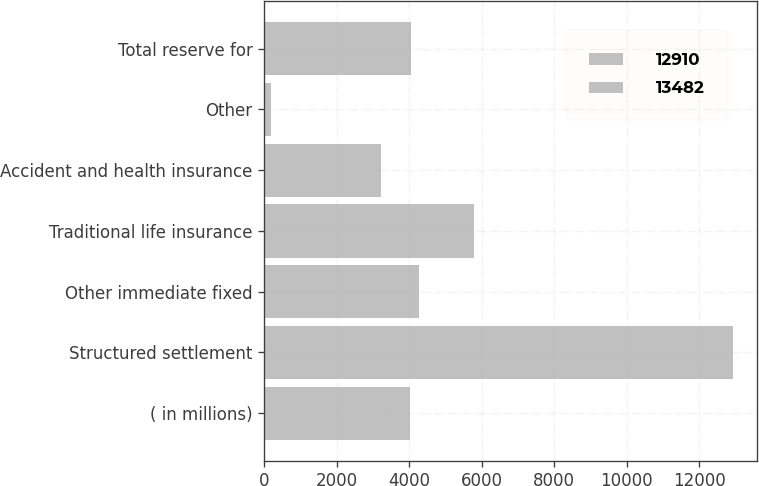Convert chart. <chart><loc_0><loc_0><loc_500><loc_500><stacked_bar_chart><ecel><fcel>( in millions)<fcel>Structured settlement<fcel>Other immediate fixed<fcel>Traditional life insurance<fcel>Accident and health insurance<fcel>Other<fcel>Total reserve for<nl><fcel>12910<fcel>2010<fcel>6522<fcel>2215<fcel>2938<fcel>1720<fcel>87<fcel>2029<nl><fcel>13482<fcel>2009<fcel>6406<fcel>2048<fcel>2850<fcel>1514<fcel>92<fcel>2029<nl></chart> 